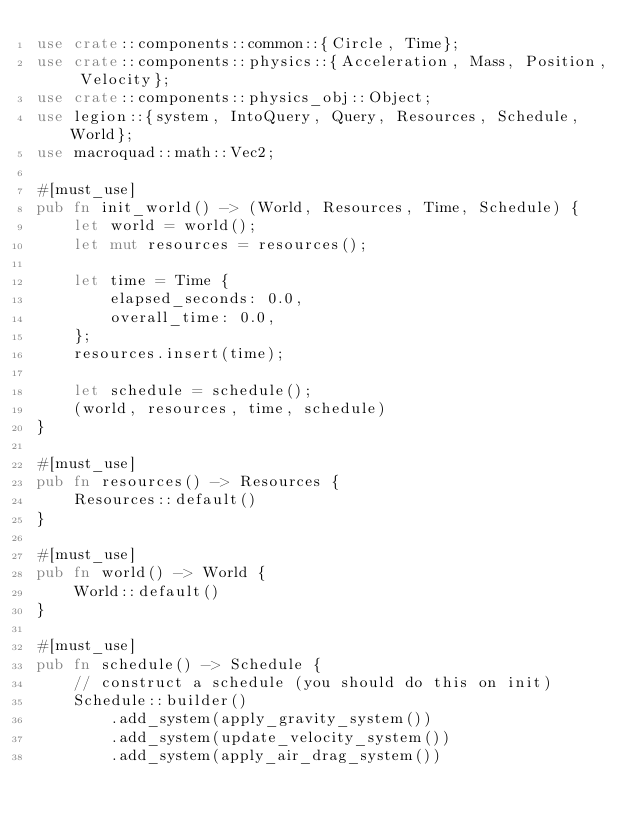Convert code to text. <code><loc_0><loc_0><loc_500><loc_500><_Rust_>use crate::components::common::{Circle, Time};
use crate::components::physics::{Acceleration, Mass, Position, Velocity};
use crate::components::physics_obj::Object;
use legion::{system, IntoQuery, Query, Resources, Schedule, World};
use macroquad::math::Vec2;

#[must_use]
pub fn init_world() -> (World, Resources, Time, Schedule) {
    let world = world();
    let mut resources = resources();

    let time = Time {
        elapsed_seconds: 0.0,
        overall_time: 0.0,
    };
    resources.insert(time);

    let schedule = schedule();
    (world, resources, time, schedule)
}

#[must_use]
pub fn resources() -> Resources {
    Resources::default()
}

#[must_use]
pub fn world() -> World {
    World::default()
}

#[must_use]
pub fn schedule() -> Schedule {
    // construct a schedule (you should do this on init)
    Schedule::builder()
        .add_system(apply_gravity_system())
        .add_system(update_velocity_system())
        .add_system(apply_air_drag_system())</code> 